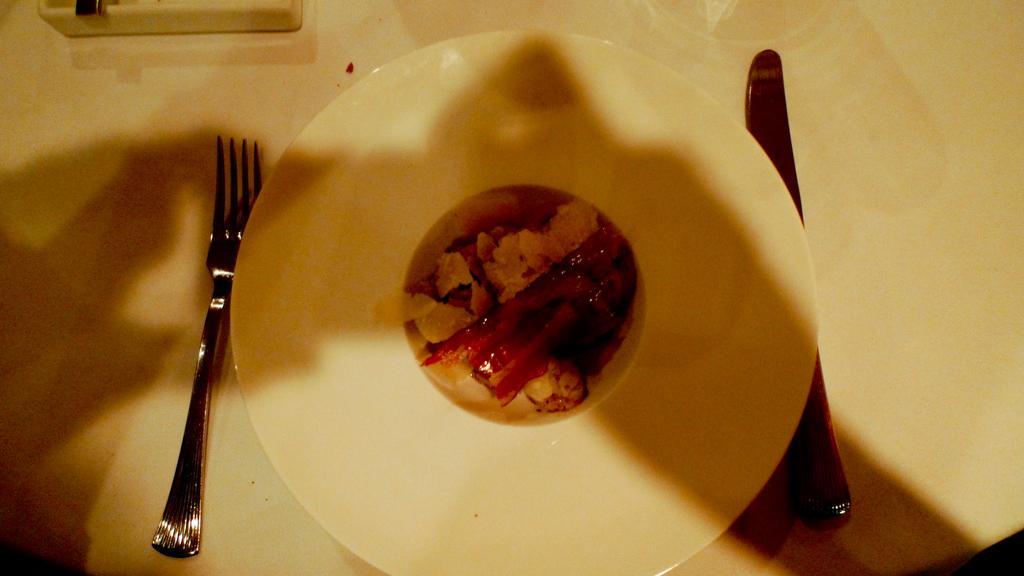In one or two sentences, can you explain what this image depicts? In this image I can see the food and the food is in cream and red color. The food is in the plate, the plate is in white color and I can see the fork and the knife on the white color object. 